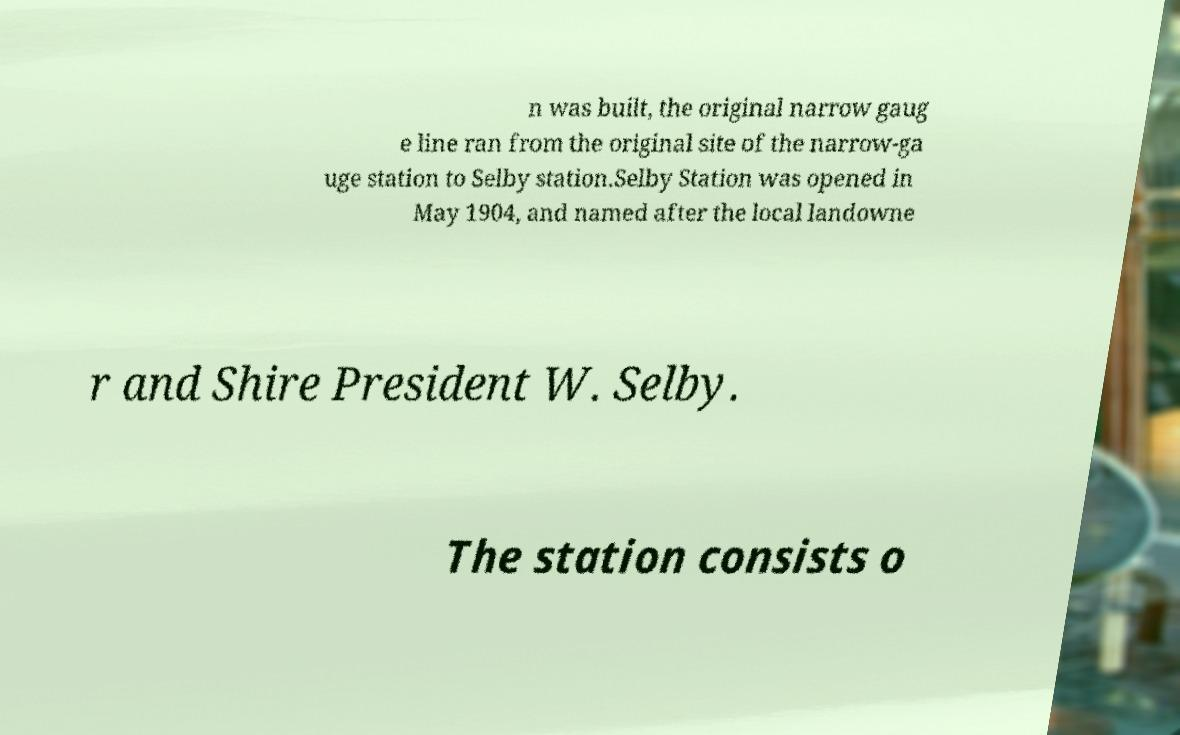Can you accurately transcribe the text from the provided image for me? n was built, the original narrow gaug e line ran from the original site of the narrow-ga uge station to Selby station.Selby Station was opened in May 1904, and named after the local landowne r and Shire President W. Selby. The station consists o 